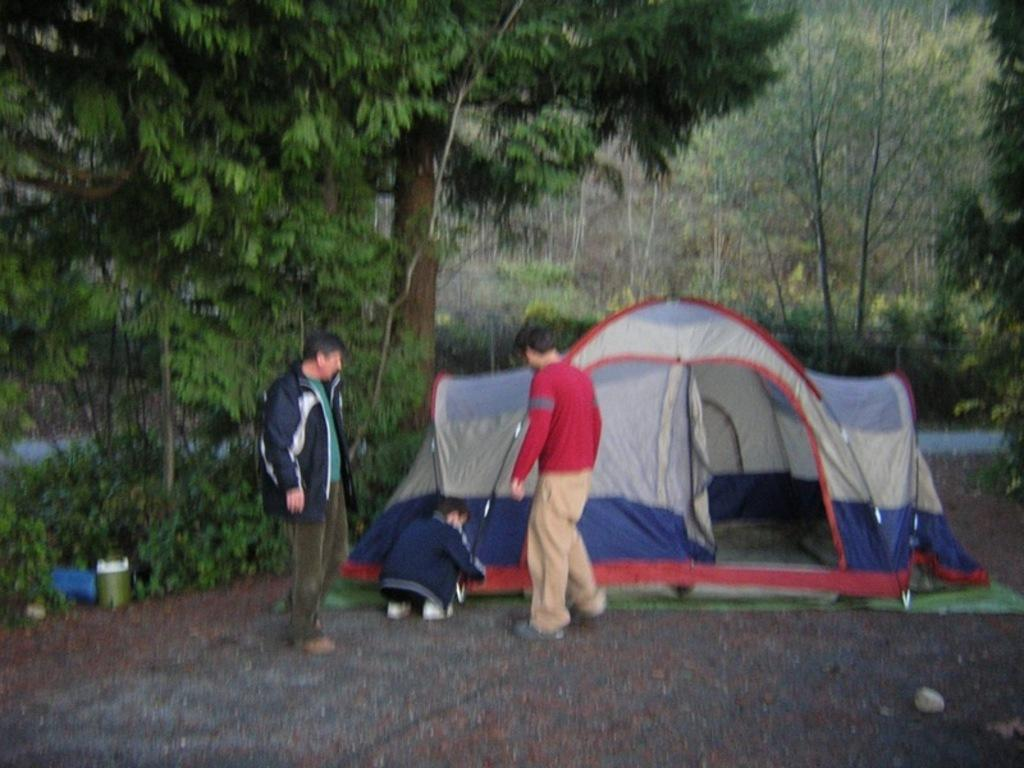What can be seen in the left corner of the image? There are trees in the left corner of the image. What can be seen in the right corner of the image? There are trees in the right corner of the image. What is located at the bottom of the image? There is a road at the bottom of the image. What is in the foreground of the image? There is a tent and people in the foreground of the image. What is visible in the background of the image? There are trees in the background of the image. Can you see the ocean in the image? No, there is no ocean visible in the image. What type of cable is being used by the people in the image? There is no cable present in the image. 